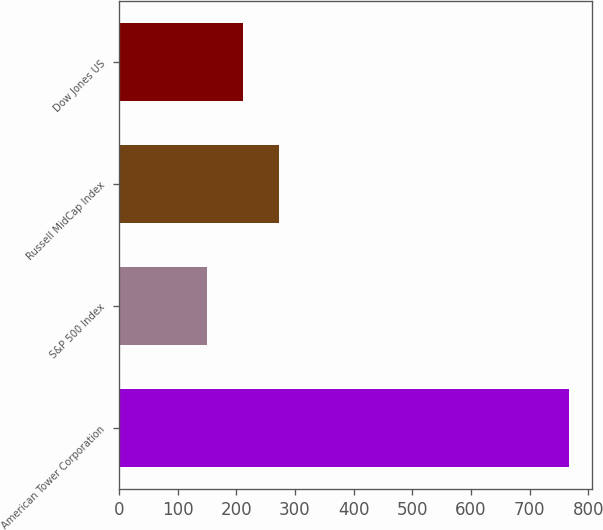<chart> <loc_0><loc_0><loc_500><loc_500><bar_chart><fcel>American Tower Corporation<fcel>S&P 500 Index<fcel>Russell MidCap Index<fcel>Dow Jones US<nl><fcel>767.71<fcel>149.7<fcel>273.3<fcel>211.5<nl></chart> 